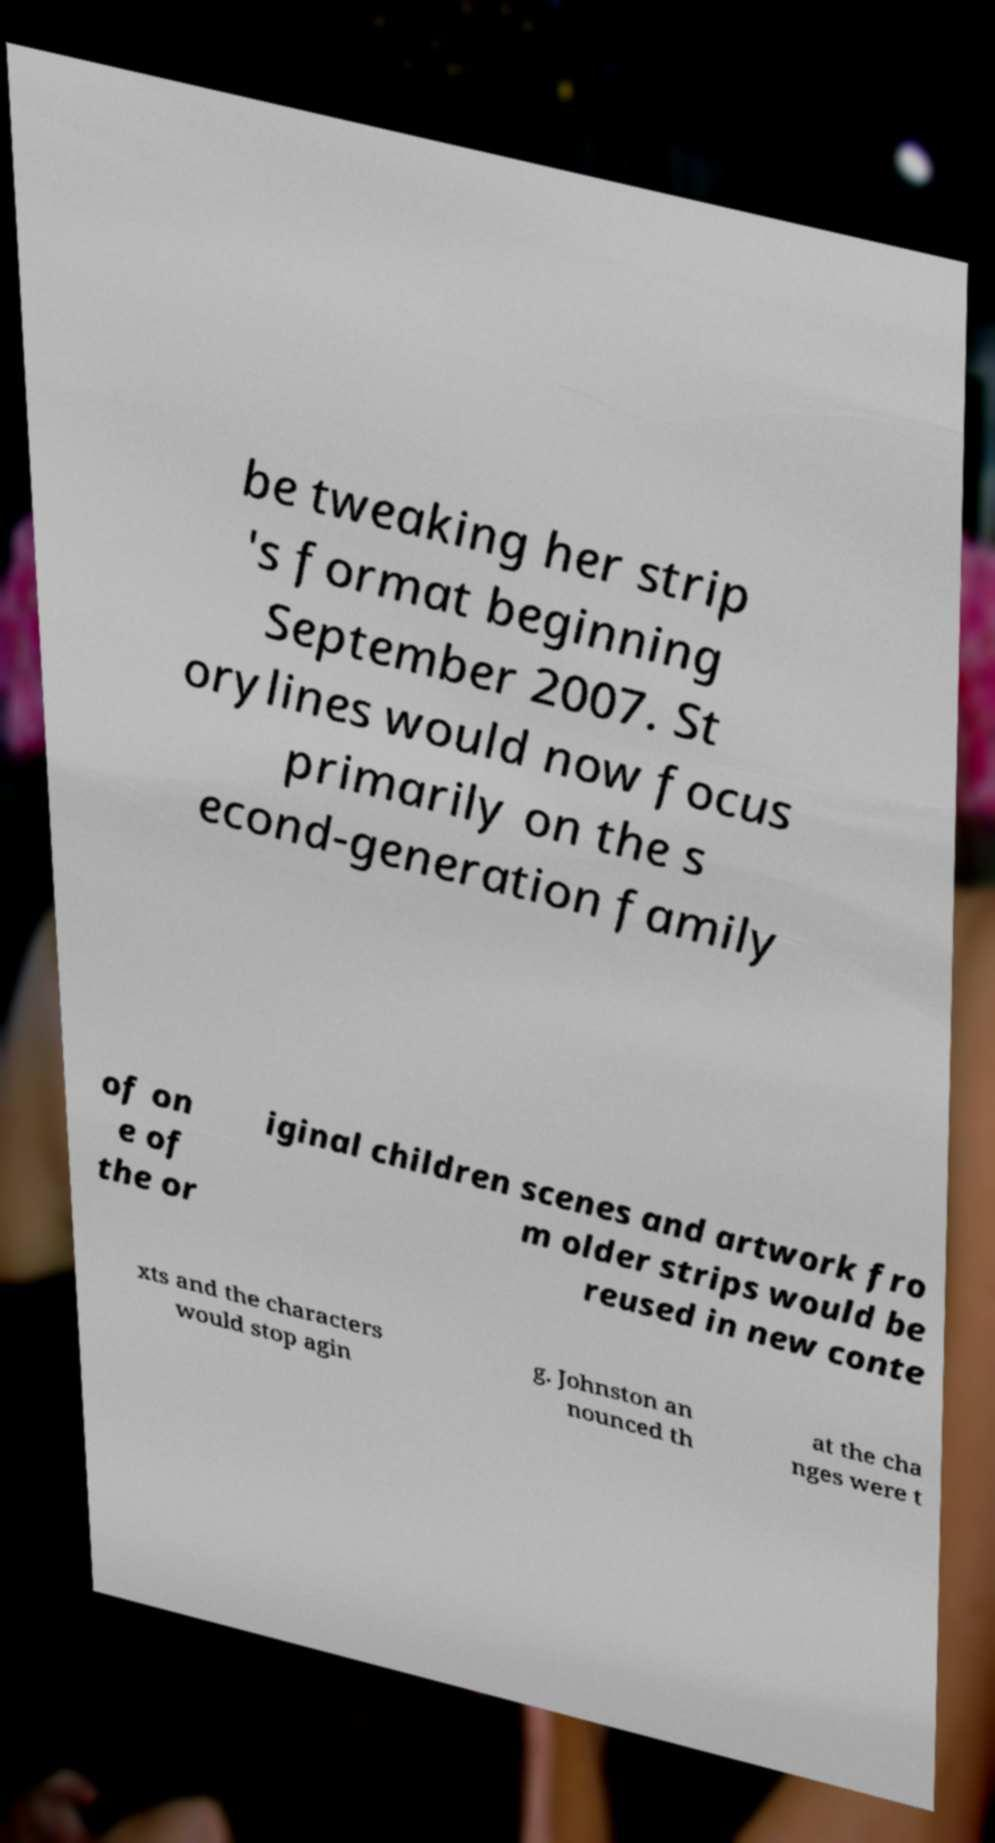Could you assist in decoding the text presented in this image and type it out clearly? be tweaking her strip 's format beginning September 2007. St orylines would now focus primarily on the s econd-generation family of on e of the or iginal children scenes and artwork fro m older strips would be reused in new conte xts and the characters would stop agin g. Johnston an nounced th at the cha nges were t 